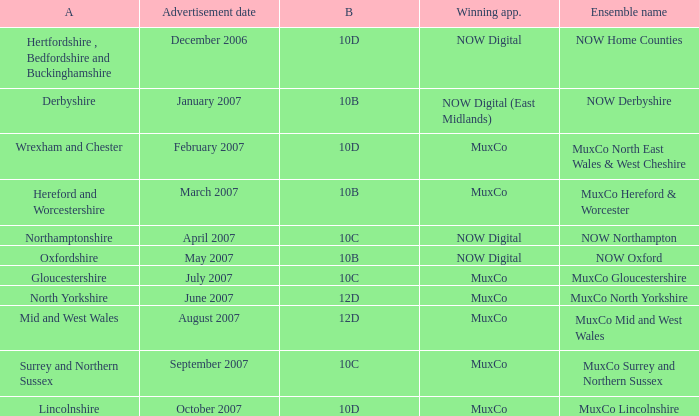Which Ensemble Name has the Advertisement date October 2007? MuxCo Lincolnshire. 